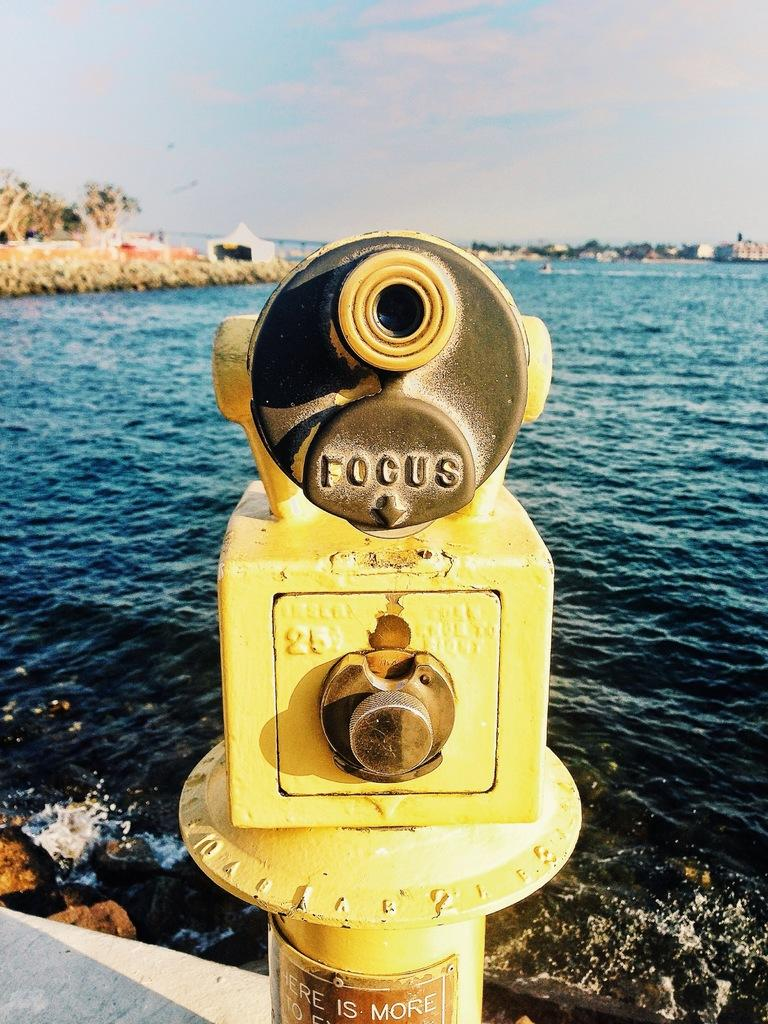What is the main object in the foreground of the picture? There is a telescope or camera-like object in the foreground of the picture. What can be seen in the center of the picture? There is a water body in the center of the picture. What type of natural elements are visible in the background of the picture? There are trees in the background of the picture. What type of man-made structures can be seen in the background of the picture? There are buildings in the background of the picture. What type of government is depicted in the image? There is no depiction of a government in the image; it features a telescope or camera-like object, a water body, trees, and buildings. What is being served for lunch in the image? There is no mention of lunch or any food items in the image. 